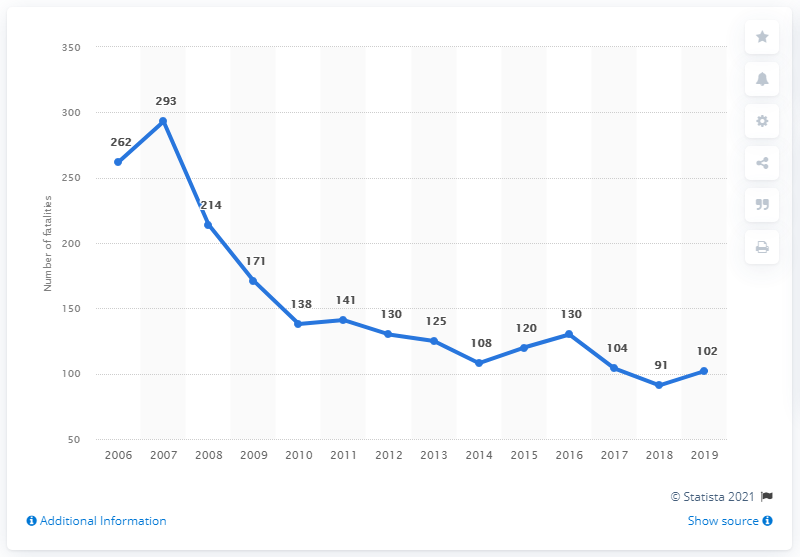Draw attention to some important aspects in this diagram. The average of 2017, 2018, and 2019 is 99. In 2008, a total of 214 fatalities were recorded. In 2019, there were 102 road traffic fatalities in Slovenia. In 2007, the highest number of road fatalities occurred in Slovenia. 